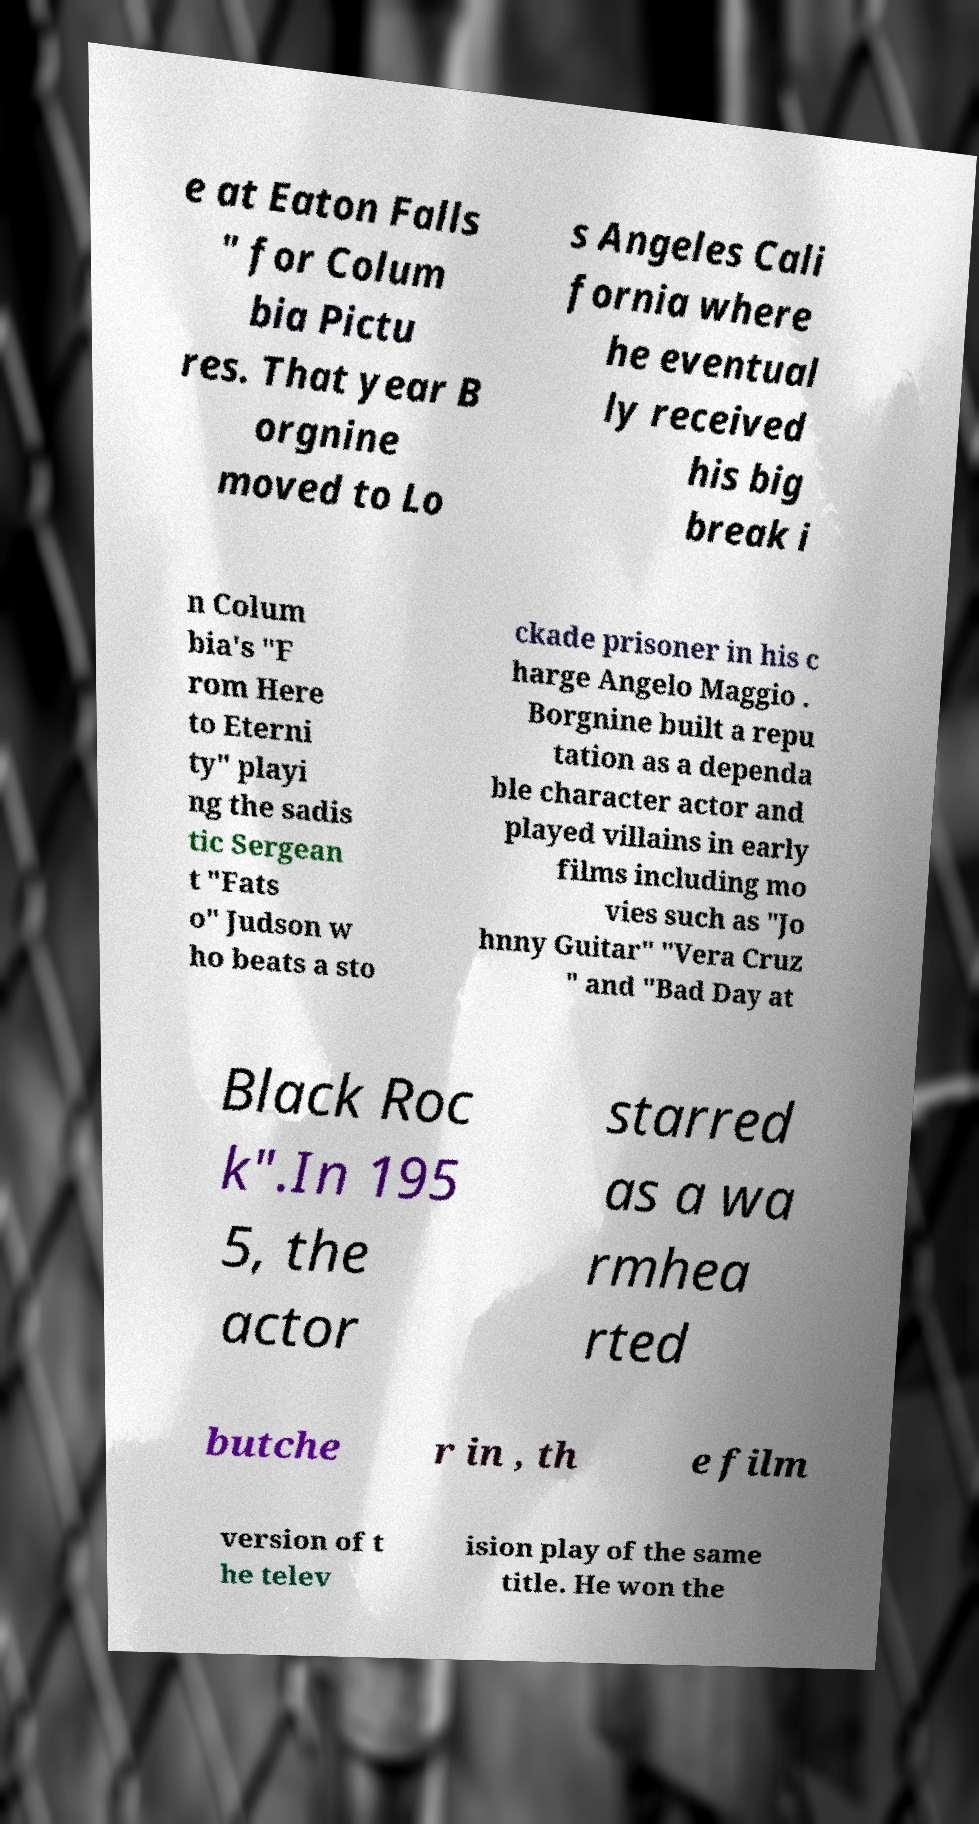Please identify and transcribe the text found in this image. e at Eaton Falls " for Colum bia Pictu res. That year B orgnine moved to Lo s Angeles Cali fornia where he eventual ly received his big break i n Colum bia's "F rom Here to Eterni ty" playi ng the sadis tic Sergean t "Fats o" Judson w ho beats a sto ckade prisoner in his c harge Angelo Maggio . Borgnine built a repu tation as a dependa ble character actor and played villains in early films including mo vies such as "Jo hnny Guitar" "Vera Cruz " and "Bad Day at Black Roc k".In 195 5, the actor starred as a wa rmhea rted butche r in , th e film version of t he telev ision play of the same title. He won the 